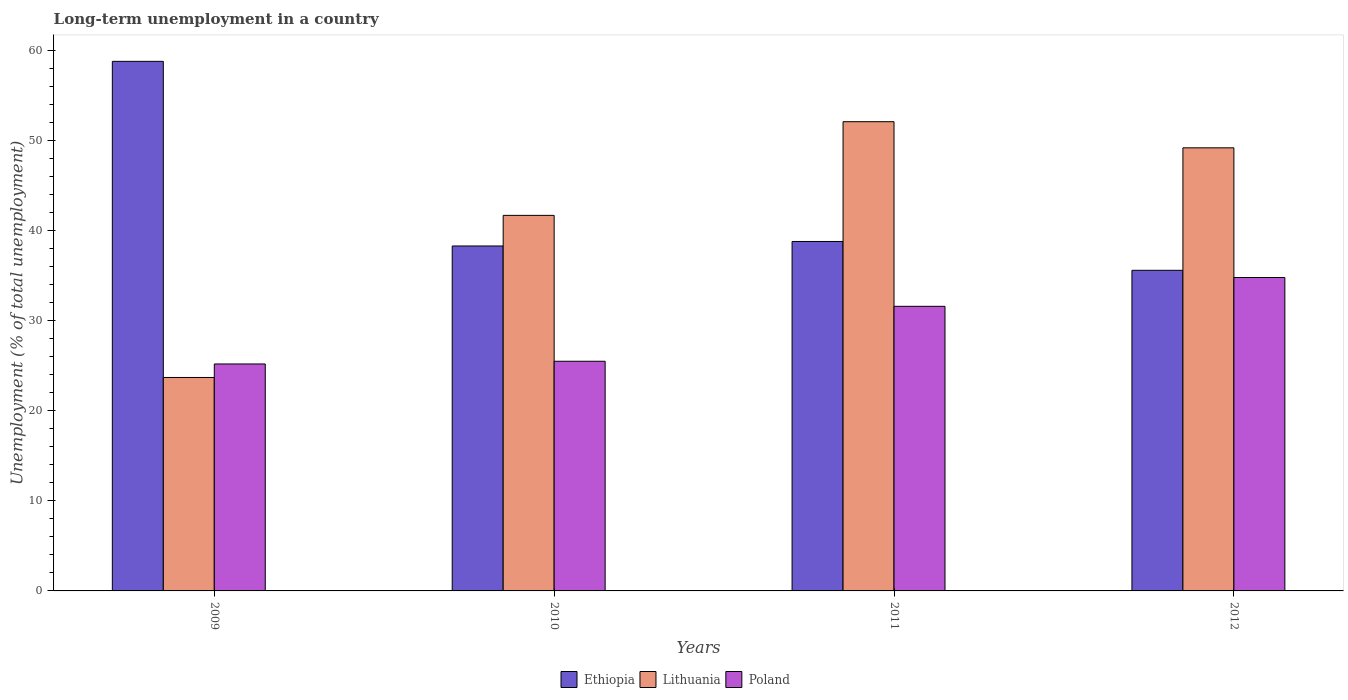How many different coloured bars are there?
Keep it short and to the point. 3. How many bars are there on the 3rd tick from the left?
Provide a short and direct response. 3. What is the label of the 2nd group of bars from the left?
Make the answer very short. 2010. What is the percentage of long-term unemployed population in Poland in 2012?
Provide a succinct answer. 34.8. Across all years, what is the maximum percentage of long-term unemployed population in Lithuania?
Ensure brevity in your answer.  52.1. Across all years, what is the minimum percentage of long-term unemployed population in Lithuania?
Give a very brief answer. 23.7. In which year was the percentage of long-term unemployed population in Lithuania maximum?
Offer a very short reply. 2011. What is the total percentage of long-term unemployed population in Lithuania in the graph?
Your answer should be very brief. 166.7. What is the difference between the percentage of long-term unemployed population in Poland in 2009 and that in 2012?
Your answer should be compact. -9.6. What is the difference between the percentage of long-term unemployed population in Lithuania in 2009 and the percentage of long-term unemployed population in Poland in 2012?
Give a very brief answer. -11.1. What is the average percentage of long-term unemployed population in Ethiopia per year?
Provide a short and direct response. 42.87. In the year 2011, what is the difference between the percentage of long-term unemployed population in Lithuania and percentage of long-term unemployed population in Poland?
Make the answer very short. 20.5. What is the ratio of the percentage of long-term unemployed population in Poland in 2009 to that in 2011?
Make the answer very short. 0.8. Is the percentage of long-term unemployed population in Lithuania in 2011 less than that in 2012?
Keep it short and to the point. No. What is the difference between the highest and the second highest percentage of long-term unemployed population in Lithuania?
Keep it short and to the point. 2.9. What is the difference between the highest and the lowest percentage of long-term unemployed population in Ethiopia?
Your answer should be very brief. 23.2. In how many years, is the percentage of long-term unemployed population in Ethiopia greater than the average percentage of long-term unemployed population in Ethiopia taken over all years?
Your answer should be compact. 1. Is the sum of the percentage of long-term unemployed population in Lithuania in 2010 and 2011 greater than the maximum percentage of long-term unemployed population in Ethiopia across all years?
Provide a succinct answer. Yes. What does the 1st bar from the left in 2012 represents?
Offer a terse response. Ethiopia. What does the 3rd bar from the right in 2010 represents?
Offer a very short reply. Ethiopia. Is it the case that in every year, the sum of the percentage of long-term unemployed population in Poland and percentage of long-term unemployed population in Lithuania is greater than the percentage of long-term unemployed population in Ethiopia?
Your response must be concise. No. Are all the bars in the graph horizontal?
Make the answer very short. No. What is the difference between two consecutive major ticks on the Y-axis?
Your response must be concise. 10. Are the values on the major ticks of Y-axis written in scientific E-notation?
Offer a terse response. No. Does the graph contain grids?
Keep it short and to the point. No. Where does the legend appear in the graph?
Your response must be concise. Bottom center. How many legend labels are there?
Your answer should be compact. 3. What is the title of the graph?
Offer a very short reply. Long-term unemployment in a country. Does "Palau" appear as one of the legend labels in the graph?
Your answer should be compact. No. What is the label or title of the X-axis?
Ensure brevity in your answer.  Years. What is the label or title of the Y-axis?
Provide a short and direct response. Unemployment (% of total unemployment). What is the Unemployment (% of total unemployment) in Ethiopia in 2009?
Offer a very short reply. 58.8. What is the Unemployment (% of total unemployment) of Lithuania in 2009?
Your answer should be very brief. 23.7. What is the Unemployment (% of total unemployment) in Poland in 2009?
Your response must be concise. 25.2. What is the Unemployment (% of total unemployment) of Ethiopia in 2010?
Provide a short and direct response. 38.3. What is the Unemployment (% of total unemployment) of Lithuania in 2010?
Make the answer very short. 41.7. What is the Unemployment (% of total unemployment) in Poland in 2010?
Ensure brevity in your answer.  25.5. What is the Unemployment (% of total unemployment) in Ethiopia in 2011?
Your response must be concise. 38.8. What is the Unemployment (% of total unemployment) in Lithuania in 2011?
Keep it short and to the point. 52.1. What is the Unemployment (% of total unemployment) of Poland in 2011?
Provide a succinct answer. 31.6. What is the Unemployment (% of total unemployment) in Ethiopia in 2012?
Your answer should be very brief. 35.6. What is the Unemployment (% of total unemployment) in Lithuania in 2012?
Offer a terse response. 49.2. What is the Unemployment (% of total unemployment) in Poland in 2012?
Make the answer very short. 34.8. Across all years, what is the maximum Unemployment (% of total unemployment) of Ethiopia?
Your response must be concise. 58.8. Across all years, what is the maximum Unemployment (% of total unemployment) in Lithuania?
Keep it short and to the point. 52.1. Across all years, what is the maximum Unemployment (% of total unemployment) in Poland?
Offer a terse response. 34.8. Across all years, what is the minimum Unemployment (% of total unemployment) of Ethiopia?
Provide a short and direct response. 35.6. Across all years, what is the minimum Unemployment (% of total unemployment) in Lithuania?
Your response must be concise. 23.7. Across all years, what is the minimum Unemployment (% of total unemployment) in Poland?
Keep it short and to the point. 25.2. What is the total Unemployment (% of total unemployment) in Ethiopia in the graph?
Your answer should be very brief. 171.5. What is the total Unemployment (% of total unemployment) in Lithuania in the graph?
Keep it short and to the point. 166.7. What is the total Unemployment (% of total unemployment) of Poland in the graph?
Provide a succinct answer. 117.1. What is the difference between the Unemployment (% of total unemployment) in Ethiopia in 2009 and that in 2011?
Ensure brevity in your answer.  20. What is the difference between the Unemployment (% of total unemployment) of Lithuania in 2009 and that in 2011?
Offer a very short reply. -28.4. What is the difference between the Unemployment (% of total unemployment) of Ethiopia in 2009 and that in 2012?
Provide a succinct answer. 23.2. What is the difference between the Unemployment (% of total unemployment) of Lithuania in 2009 and that in 2012?
Make the answer very short. -25.5. What is the difference between the Unemployment (% of total unemployment) in Poland in 2010 and that in 2011?
Your answer should be very brief. -6.1. What is the difference between the Unemployment (% of total unemployment) in Lithuania in 2010 and that in 2012?
Ensure brevity in your answer.  -7.5. What is the difference between the Unemployment (% of total unemployment) in Ethiopia in 2009 and the Unemployment (% of total unemployment) in Poland in 2010?
Make the answer very short. 33.3. What is the difference between the Unemployment (% of total unemployment) of Lithuania in 2009 and the Unemployment (% of total unemployment) of Poland in 2010?
Provide a succinct answer. -1.8. What is the difference between the Unemployment (% of total unemployment) in Ethiopia in 2009 and the Unemployment (% of total unemployment) in Lithuania in 2011?
Make the answer very short. 6.7. What is the difference between the Unemployment (% of total unemployment) in Ethiopia in 2009 and the Unemployment (% of total unemployment) in Poland in 2011?
Your answer should be very brief. 27.2. What is the difference between the Unemployment (% of total unemployment) in Lithuania in 2009 and the Unemployment (% of total unemployment) in Poland in 2011?
Make the answer very short. -7.9. What is the difference between the Unemployment (% of total unemployment) of Ethiopia in 2010 and the Unemployment (% of total unemployment) of Poland in 2011?
Offer a terse response. 6.7. What is the difference between the Unemployment (% of total unemployment) in Ethiopia in 2010 and the Unemployment (% of total unemployment) in Lithuania in 2012?
Keep it short and to the point. -10.9. What is the difference between the Unemployment (% of total unemployment) in Ethiopia in 2010 and the Unemployment (% of total unemployment) in Poland in 2012?
Make the answer very short. 3.5. What is the average Unemployment (% of total unemployment) of Ethiopia per year?
Offer a very short reply. 42.88. What is the average Unemployment (% of total unemployment) in Lithuania per year?
Provide a succinct answer. 41.67. What is the average Unemployment (% of total unemployment) in Poland per year?
Your answer should be very brief. 29.27. In the year 2009, what is the difference between the Unemployment (% of total unemployment) in Ethiopia and Unemployment (% of total unemployment) in Lithuania?
Offer a very short reply. 35.1. In the year 2009, what is the difference between the Unemployment (% of total unemployment) of Ethiopia and Unemployment (% of total unemployment) of Poland?
Make the answer very short. 33.6. In the year 2009, what is the difference between the Unemployment (% of total unemployment) in Lithuania and Unemployment (% of total unemployment) in Poland?
Give a very brief answer. -1.5. In the year 2010, what is the difference between the Unemployment (% of total unemployment) in Ethiopia and Unemployment (% of total unemployment) in Lithuania?
Make the answer very short. -3.4. In the year 2010, what is the difference between the Unemployment (% of total unemployment) of Ethiopia and Unemployment (% of total unemployment) of Poland?
Offer a very short reply. 12.8. In the year 2011, what is the difference between the Unemployment (% of total unemployment) of Ethiopia and Unemployment (% of total unemployment) of Lithuania?
Give a very brief answer. -13.3. In the year 2012, what is the difference between the Unemployment (% of total unemployment) of Ethiopia and Unemployment (% of total unemployment) of Poland?
Keep it short and to the point. 0.8. In the year 2012, what is the difference between the Unemployment (% of total unemployment) of Lithuania and Unemployment (% of total unemployment) of Poland?
Offer a terse response. 14.4. What is the ratio of the Unemployment (% of total unemployment) of Ethiopia in 2009 to that in 2010?
Give a very brief answer. 1.54. What is the ratio of the Unemployment (% of total unemployment) of Lithuania in 2009 to that in 2010?
Provide a succinct answer. 0.57. What is the ratio of the Unemployment (% of total unemployment) of Poland in 2009 to that in 2010?
Offer a terse response. 0.99. What is the ratio of the Unemployment (% of total unemployment) in Ethiopia in 2009 to that in 2011?
Give a very brief answer. 1.52. What is the ratio of the Unemployment (% of total unemployment) in Lithuania in 2009 to that in 2011?
Make the answer very short. 0.45. What is the ratio of the Unemployment (% of total unemployment) of Poland in 2009 to that in 2011?
Offer a terse response. 0.8. What is the ratio of the Unemployment (% of total unemployment) of Ethiopia in 2009 to that in 2012?
Give a very brief answer. 1.65. What is the ratio of the Unemployment (% of total unemployment) in Lithuania in 2009 to that in 2012?
Your answer should be very brief. 0.48. What is the ratio of the Unemployment (% of total unemployment) of Poland in 2009 to that in 2012?
Provide a short and direct response. 0.72. What is the ratio of the Unemployment (% of total unemployment) in Ethiopia in 2010 to that in 2011?
Your response must be concise. 0.99. What is the ratio of the Unemployment (% of total unemployment) of Lithuania in 2010 to that in 2011?
Keep it short and to the point. 0.8. What is the ratio of the Unemployment (% of total unemployment) of Poland in 2010 to that in 2011?
Offer a very short reply. 0.81. What is the ratio of the Unemployment (% of total unemployment) in Ethiopia in 2010 to that in 2012?
Make the answer very short. 1.08. What is the ratio of the Unemployment (% of total unemployment) in Lithuania in 2010 to that in 2012?
Provide a short and direct response. 0.85. What is the ratio of the Unemployment (% of total unemployment) of Poland in 2010 to that in 2012?
Your response must be concise. 0.73. What is the ratio of the Unemployment (% of total unemployment) in Ethiopia in 2011 to that in 2012?
Your answer should be compact. 1.09. What is the ratio of the Unemployment (% of total unemployment) of Lithuania in 2011 to that in 2012?
Your answer should be very brief. 1.06. What is the ratio of the Unemployment (% of total unemployment) of Poland in 2011 to that in 2012?
Give a very brief answer. 0.91. What is the difference between the highest and the second highest Unemployment (% of total unemployment) of Lithuania?
Make the answer very short. 2.9. What is the difference between the highest and the lowest Unemployment (% of total unemployment) in Ethiopia?
Provide a succinct answer. 23.2. What is the difference between the highest and the lowest Unemployment (% of total unemployment) of Lithuania?
Keep it short and to the point. 28.4. What is the difference between the highest and the lowest Unemployment (% of total unemployment) of Poland?
Offer a very short reply. 9.6. 